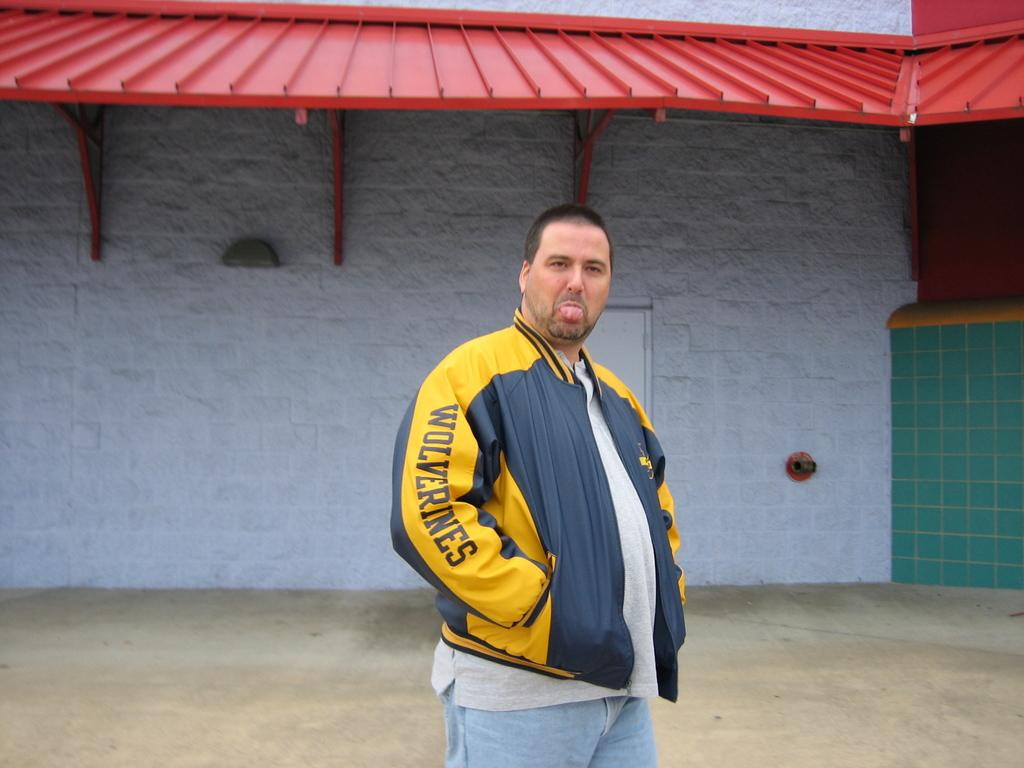<image>
Offer a succinct explanation of the picture presented. A fat man wearing a blue and yellow Wolverines jacket sticks his tongue out with his hands in his pockets. 